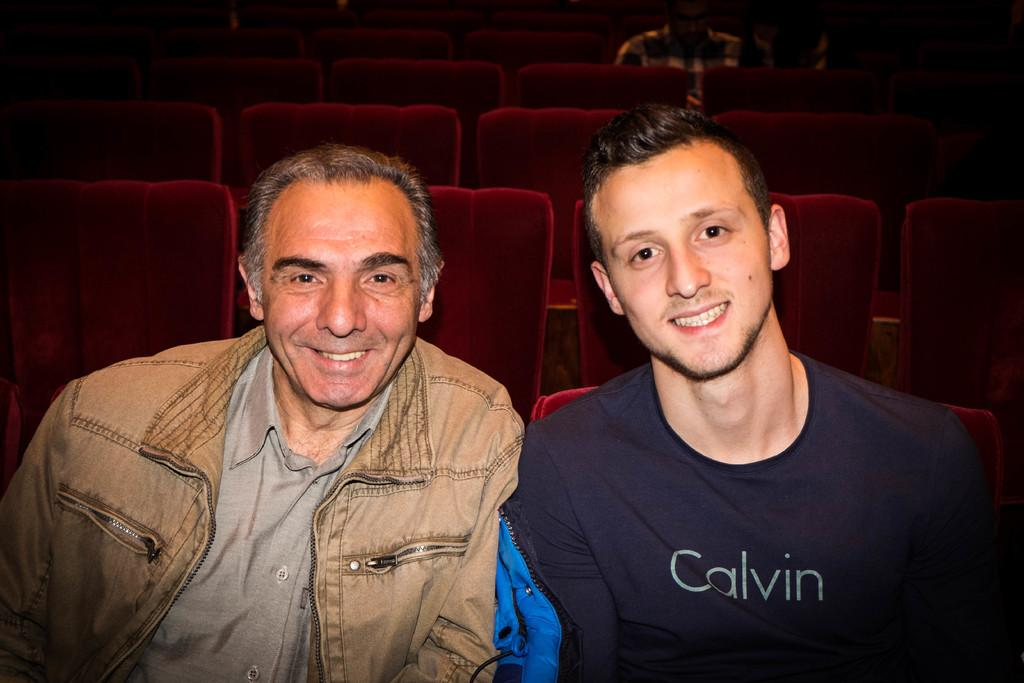What type of furniture is present in the image? There are chairs in the image. How many men are sitting on chairs in the foreground? Two men are sitting on chairs in the foreground. What is the facial expression of the two men in the foreground? The two men in the foreground are smiling. Can you describe the man sitting on a chair in the background? There is a man sitting on a chair in the background. What type of bubble is floating near the men in the image? There is no bubble present in the image. Can you describe the rabbit sitting next to the man in the foreground? There is no rabbit present in the image. 